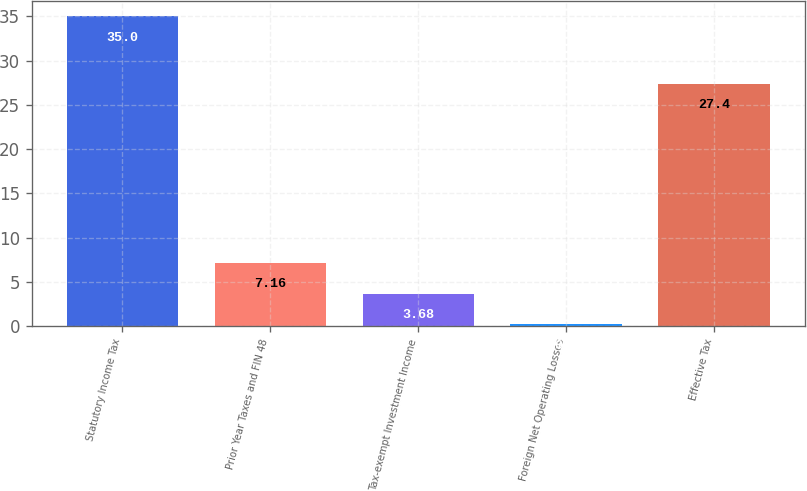Convert chart. <chart><loc_0><loc_0><loc_500><loc_500><bar_chart><fcel>Statutory Income Tax<fcel>Prior Year Taxes and FIN 48<fcel>Tax-exempt Investment Income<fcel>Foreign Net Operating Losses<fcel>Effective Tax<nl><fcel>35<fcel>7.16<fcel>3.68<fcel>0.2<fcel>27.4<nl></chart> 